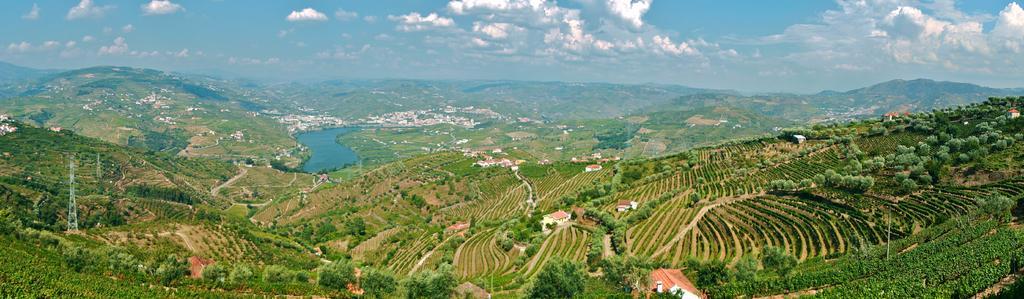Describe this image in one or two sentences. This picture might be taken outside of the city. In this picture, on the right side, we can see some houses, plants, trees. On the left side, there is a water. In the background, we can see mountains, buildings. On the top there is a sky, at the bottom, we can see some plants and a grass. 